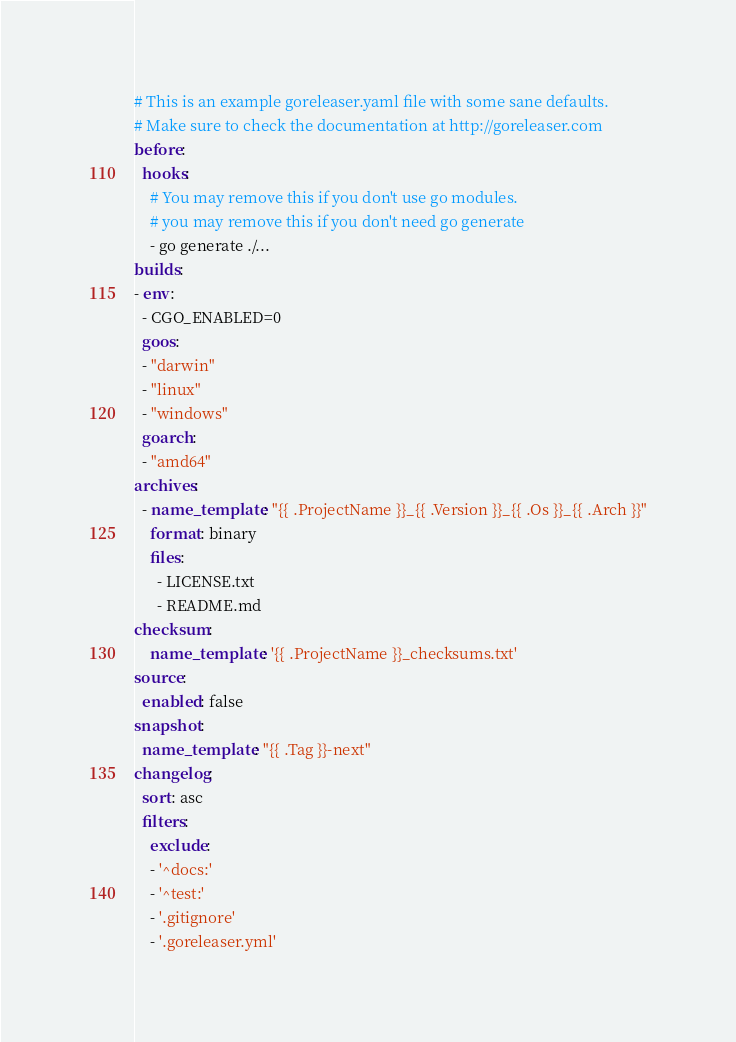<code> <loc_0><loc_0><loc_500><loc_500><_YAML_># This is an example goreleaser.yaml file with some sane defaults.
# Make sure to check the documentation at http://goreleaser.com
before:
  hooks:
    # You may remove this if you don't use go modules.
    # you may remove this if you don't need go generate
    - go generate ./...
builds:
- env:
  - CGO_ENABLED=0
  goos:
  - "darwin"
  - "linux"
  - "windows"
  goarch:
  - "amd64"
archives:
  - name_template: "{{ .ProjectName }}_{{ .Version }}_{{ .Os }}_{{ .Arch }}"
    format: binary
    files:
      - LICENSE.txt
      - README.md
checksum:
    name_template: '{{ .ProjectName }}_checksums.txt'
source:
  enabled: false
snapshot:
  name_template: "{{ .Tag }}-next"
changelog:
  sort: asc
  filters:
    exclude:
    - '^docs:'
    - '^test:'
    - '.gitignore'
    - '.goreleaser.yml'
</code> 